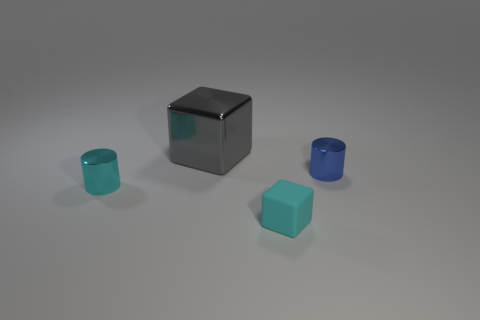Add 1 big brown cubes. How many objects exist? 5 Subtract all cyan cylinders. Subtract all purple spheres. How many cylinders are left? 1 Subtract all small matte balls. Subtract all small cyan blocks. How many objects are left? 3 Add 2 small objects. How many small objects are left? 5 Add 3 brown shiny balls. How many brown shiny balls exist? 3 Subtract 0 cyan balls. How many objects are left? 4 